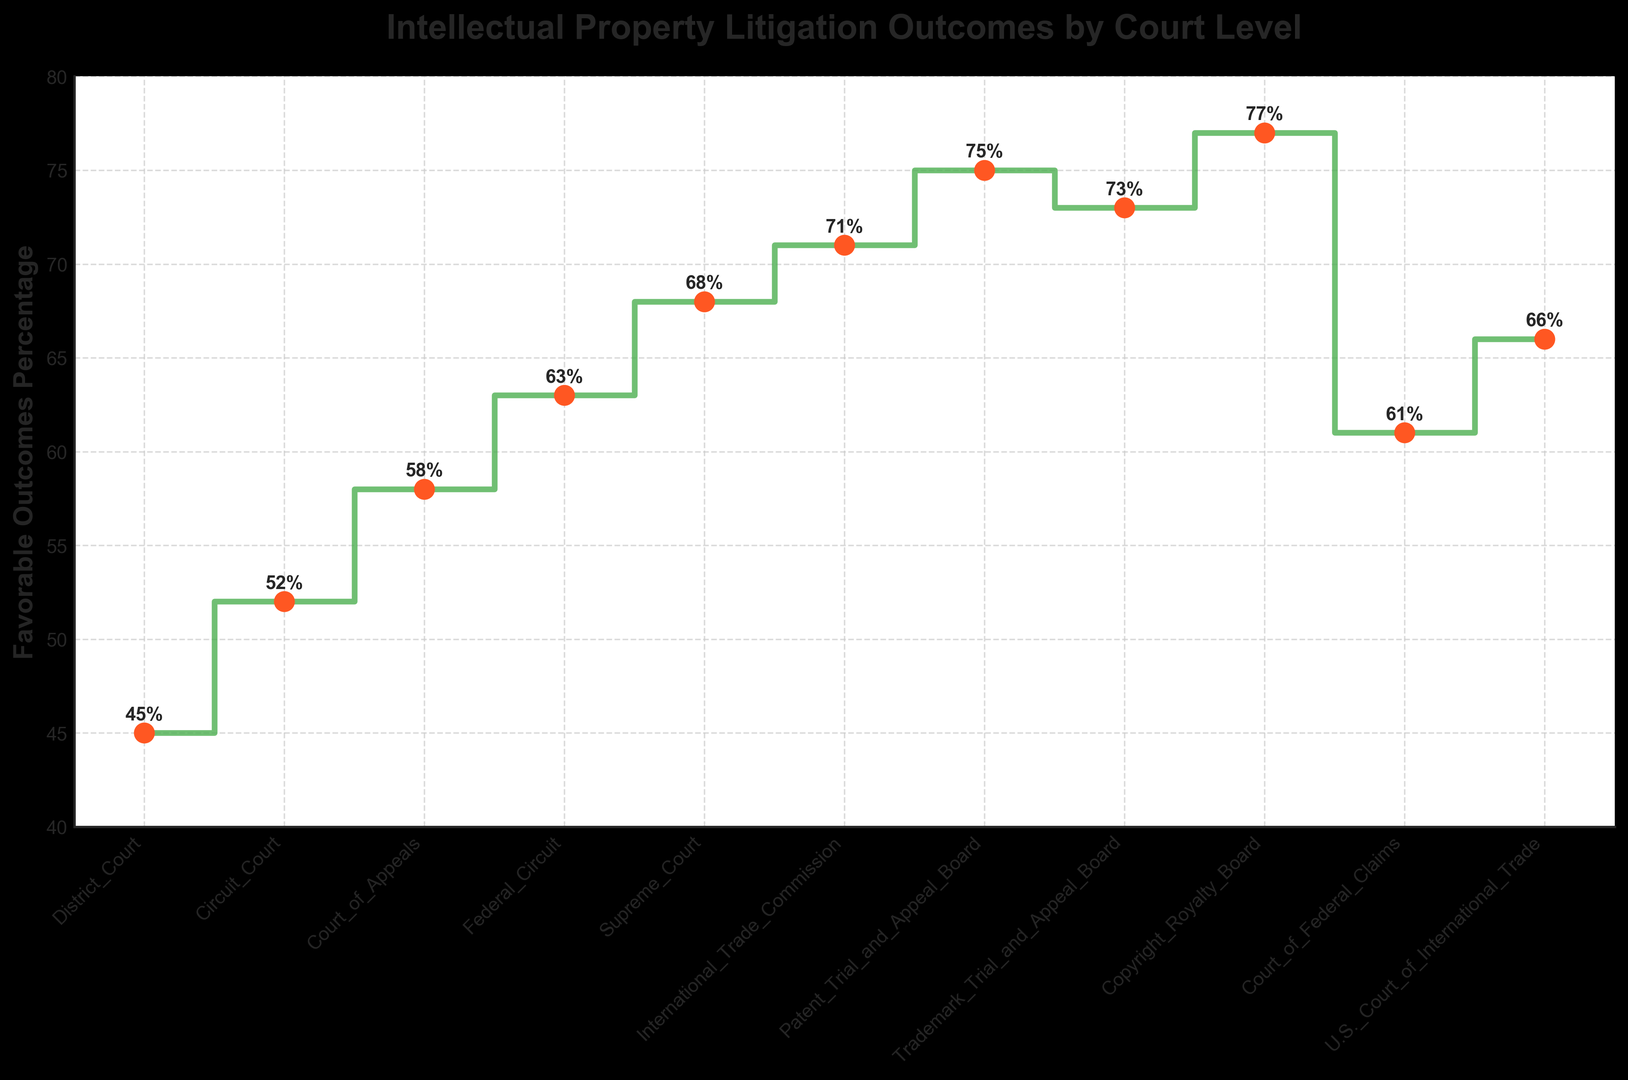What is the court level with the highest percentage of favorable outcomes? The highest point on the plot corresponds to the highest percentage of favorable outcomes. The data point at the top of the stairs plot shows the Copyright Royalty Board with 77%.
Answer: Copyright Royalty Board How much higher is the favorable outcome percentage at the Supreme Court compared to the District Court? Find the percentages for both the Supreme Court (68%) and the District Court (45%) on the plot. Subtract the District Court percentage from the Supreme Court percentage: 68% - 45% = 23%.
Answer: 23% What is the average favorable outcomes percentage for the Circuit Court, Court of Appeals, and Federal Circuit? Add the percentages for the Circuit Court (52%), Court of Appeals (58%), and Federal Circuit (63%). Then divide by the number of courts: (52% + 58% + 63%) / 3 = 57.67%.
Answer: 57.67% Which two court levels have the closest favorable outcomes percentage, and what is the difference between them? Look for court levels with nearly equal values. The Trademark Trial and Appeal Board (73%) and International Trade Commission (71%) are closest. Subtract the smaller percentage from the larger one: 73% - 71% = 2%.
Answer: Trademark Trial and Appeal Board and International Trade Commission, 2% Is there a court level where the favorable outcomes percentage is greater than 70% but less than 75%, and if so, which one? Scan the plot for percentages in this range. The International Trade Commission (71%), Trademark Trial and Appeal Board (73%), and Patent Trial and Appeal Board (75%) fit this range, but only the first two are strictly less than 75%.
Answer: International Trade Commission and Trademark Trial and Appeal Board What is the total difference in favorable outcomes percentage from the lowest to the highest court level? Identify the lowest (District Court, 45%) and highest (Copyright Royalty Board, 77%) percentages. Subtract the lowest from the highest percentage: 77% - 45% = 32%.
Answer: 32% Which court levels have a percentage of favorable outcomes exactly equal to or more than 60%? Look for court levels with a percentage at or above 60%. These include the Court of Appeals (58%), Federal Circuit (63%), Supreme Court (68%), International Trade Commission (71%), Patent Trial and Appeal Board (75%), and Copyright Royalty Board (77%).
Answer: Federal Circuit, Supreme Court, International Trade Commission, Patent Trial and Appeal Board, Copyright Royalty Board How many court levels have favorable outcomes percentage greater than 50%? Count the number of court levels above the 50% mark. The Circuit Court (52%) onwards, totaling nine court levels, exceed 50%.
Answer: 9 